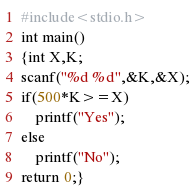<code> <loc_0><loc_0><loc_500><loc_500><_C_>#include<stdio.h>
int main()
{int X,K;
scanf("%d %d",&K,&X);
if(500*K>=X)
	printf("Yes");
else
	printf("No");
return 0;}</code> 